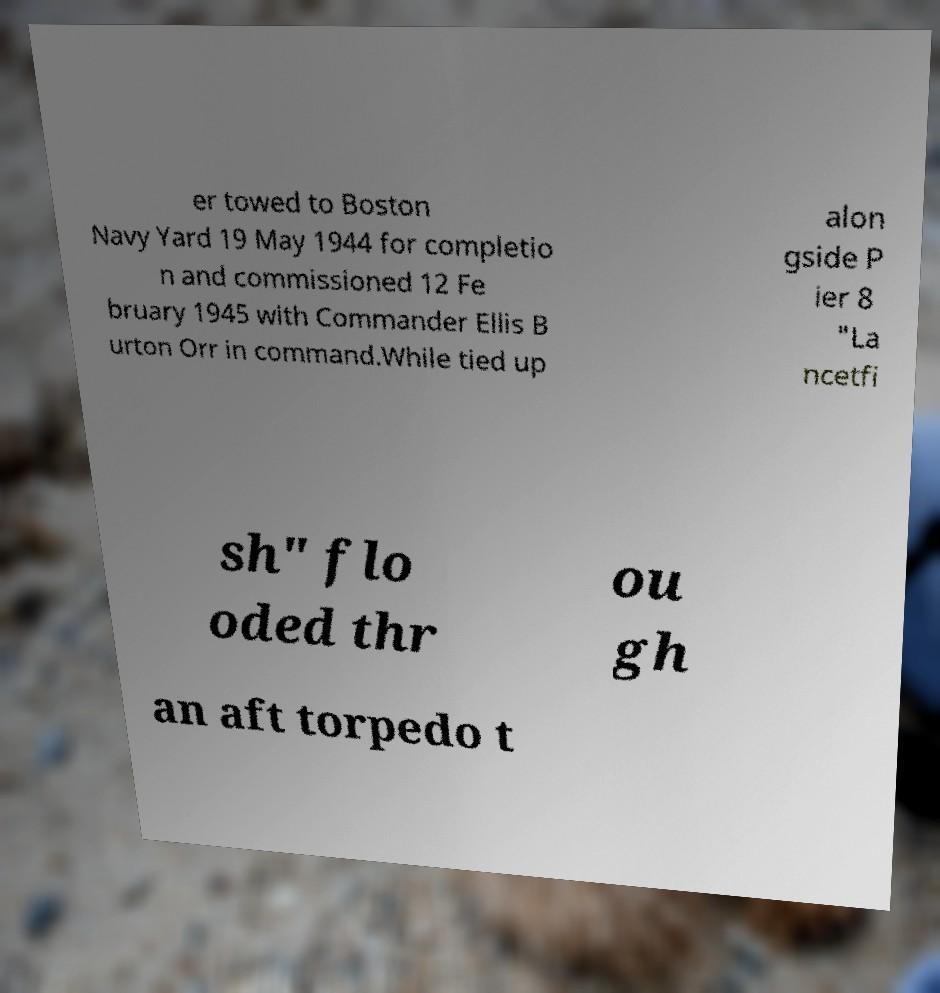I need the written content from this picture converted into text. Can you do that? er towed to Boston Navy Yard 19 May 1944 for completio n and commissioned 12 Fe bruary 1945 with Commander Ellis B urton Orr in command.While tied up alon gside P ier 8 "La ncetfi sh" flo oded thr ou gh an aft torpedo t 